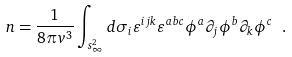Convert formula to latex. <formula><loc_0><loc_0><loc_500><loc_500>n = \frac { 1 } { 8 \pi v ^ { 3 } } \int _ { s ^ { 2 } _ { \infty } } d \sigma _ { i } \varepsilon ^ { i j k } \varepsilon ^ { a b c } \phi ^ { a } \partial _ { j } \phi ^ { b } \partial _ { k } \phi ^ { c } \ .</formula> 